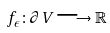Convert formula to latex. <formula><loc_0><loc_0><loc_500><loc_500>f _ { \epsilon } \colon \partial V \longrightarrow \mathbb { R }</formula> 